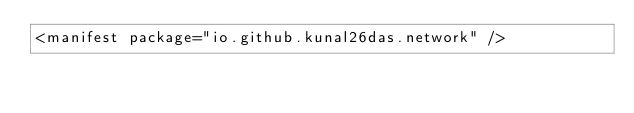Convert code to text. <code><loc_0><loc_0><loc_500><loc_500><_XML_><manifest package="io.github.kunal26das.network" /></code> 